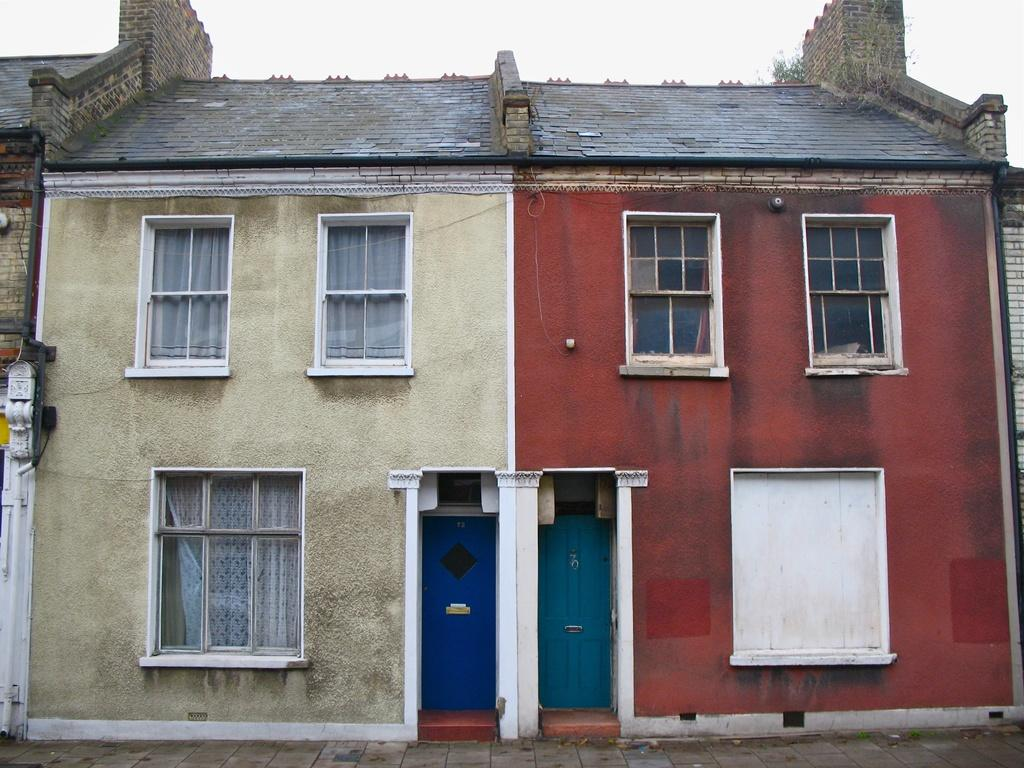What type of structure is in the image? There is a building in the image. What colors are used on the building? The building has cream and red colors. What color are the doors on the building? There are blue doors on the building. Are there any openings in the building? Yes, there are windows on the building. What is visible at the top of the image? The sky is visible at the top of the image. Who is the creator of the tent in the image? There is no tent present in the image. Can you tell me how the building is burning in the image? The building is not burning in the image; it is a static structure with no indication of fire or damage. 